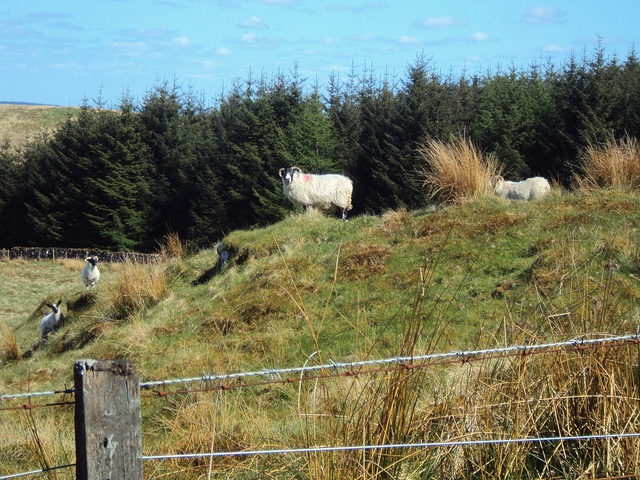Describe the objects in this image and their specific colors. I can see sheep in lightblue, beige, gray, and darkgray tones, sheep in lightblue, beige, darkgray, and gray tones, sheep in lightblue, black, gray, and darkgray tones, and sheep in lightblue, gray, darkgray, ivory, and olive tones in this image. 